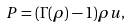Convert formula to latex. <formula><loc_0><loc_0><loc_500><loc_500>P = ( \Gamma ( \rho ) - 1 ) \rho u ,</formula> 